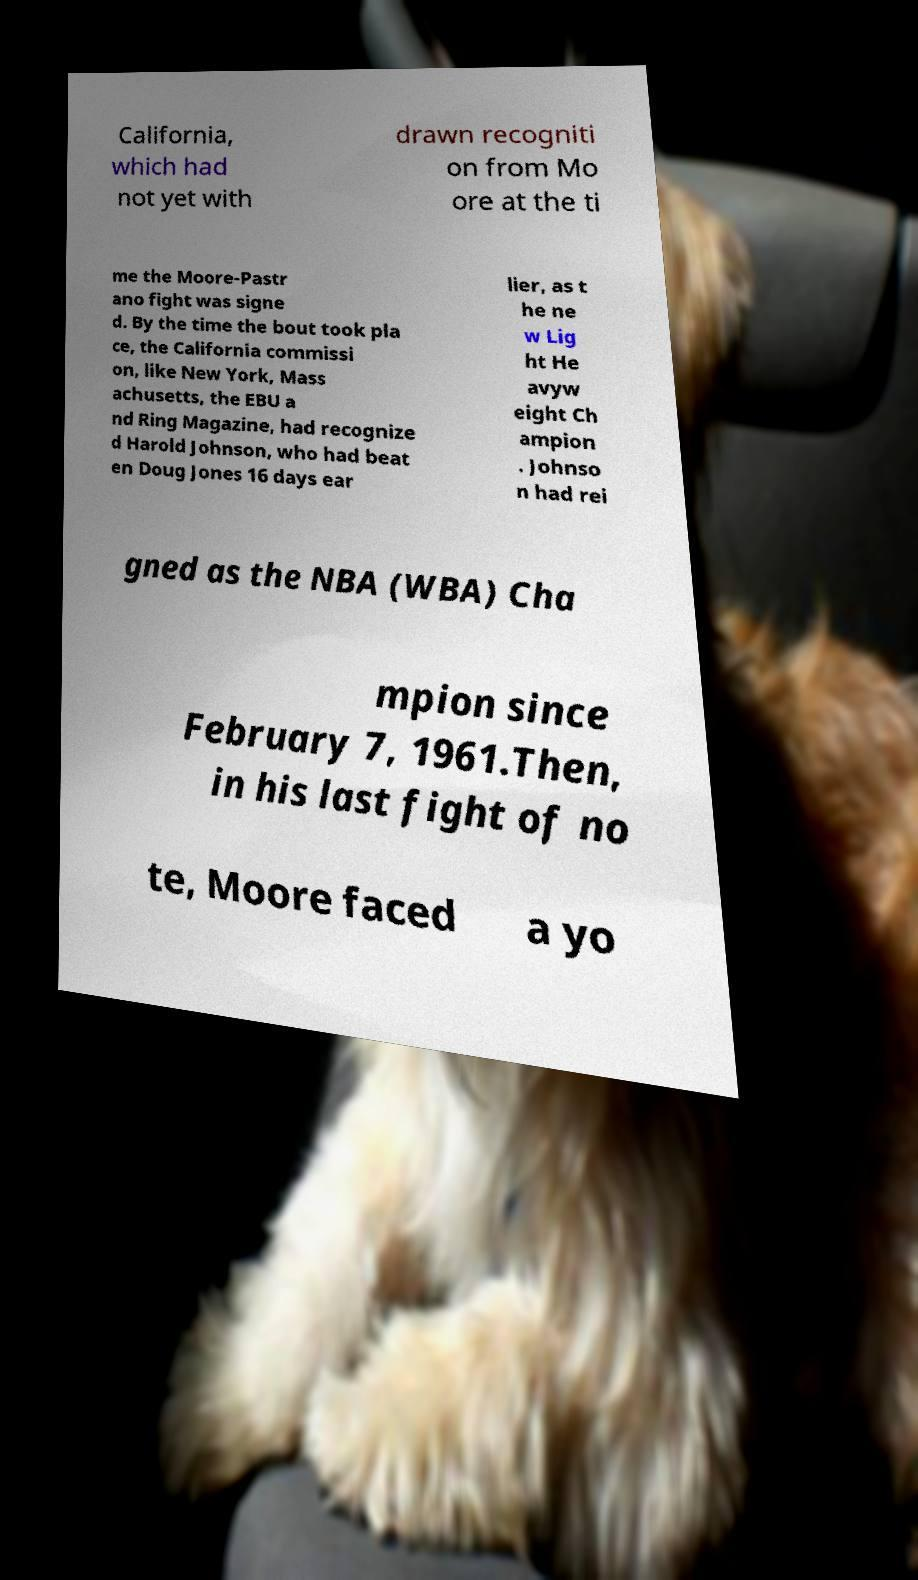Can you accurately transcribe the text from the provided image for me? California, which had not yet with drawn recogniti on from Mo ore at the ti me the Moore-Pastr ano fight was signe d. By the time the bout took pla ce, the California commissi on, like New York, Mass achusetts, the EBU a nd Ring Magazine, had recognize d Harold Johnson, who had beat en Doug Jones 16 days ear lier, as t he ne w Lig ht He avyw eight Ch ampion . Johnso n had rei gned as the NBA (WBA) Cha mpion since February 7, 1961.Then, in his last fight of no te, Moore faced a yo 